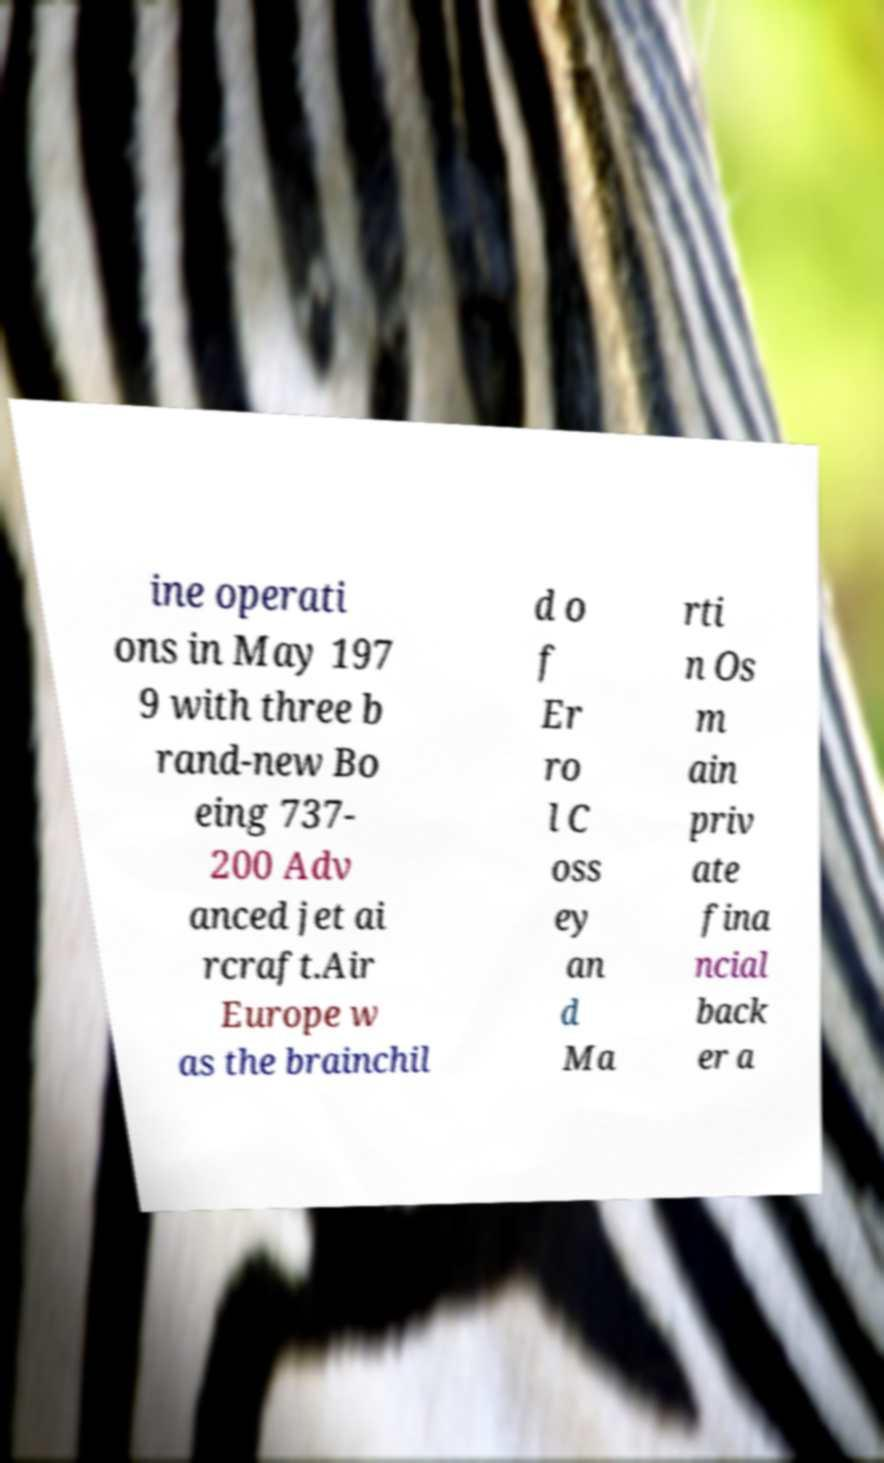Can you accurately transcribe the text from the provided image for me? ine operati ons in May 197 9 with three b rand-new Bo eing 737- 200 Adv anced jet ai rcraft.Air Europe w as the brainchil d o f Er ro l C oss ey an d Ma rti n Os m ain priv ate fina ncial back er a 